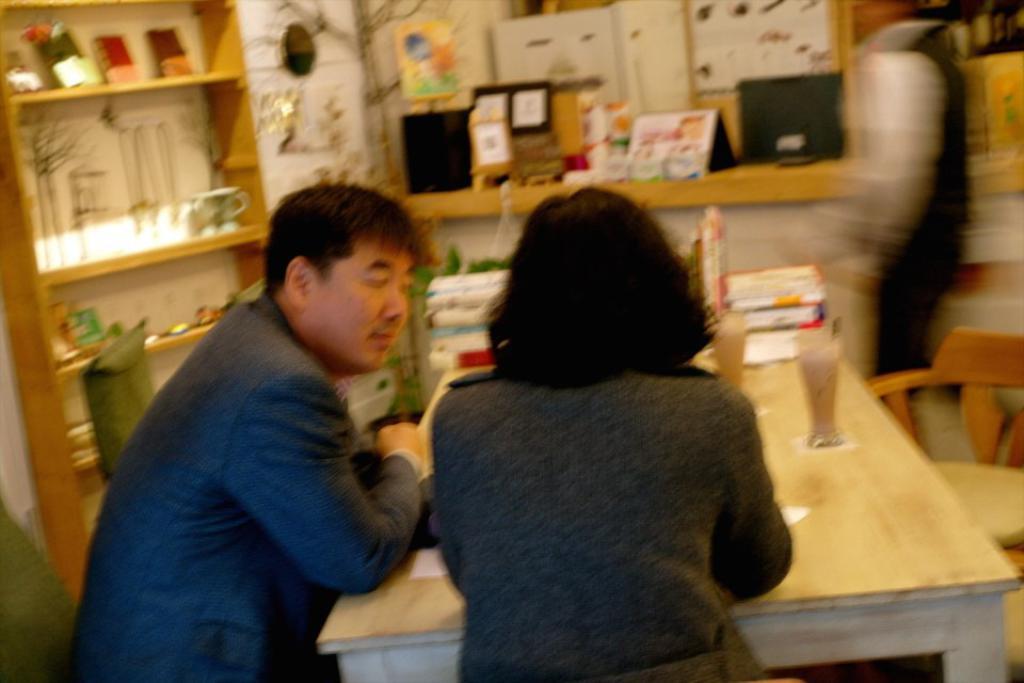Please provide a concise description of this image. In the image we can see there are people who are sitting on chair and on table there are juice glasses and books and on table there are decorative items and in shelf there are cup and other paper items. 